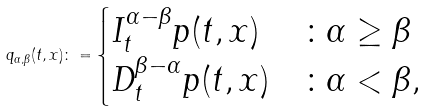<formula> <loc_0><loc_0><loc_500><loc_500>q _ { \alpha , \beta } ( t , x ) \colon = \begin{cases} I _ { t } ^ { \alpha - \beta } p ( t , x ) & \colon \alpha \geq \beta \\ D _ { t } ^ { \beta - \alpha } p ( t , x ) & \colon \alpha < \beta , \end{cases}</formula> 